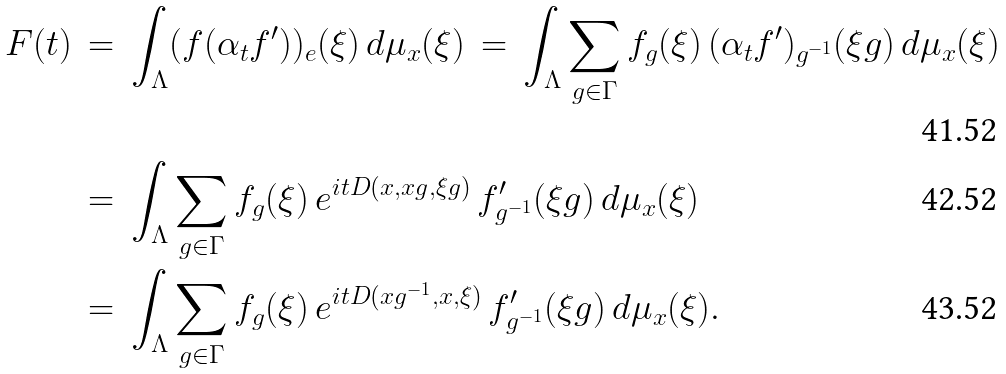Convert formula to latex. <formula><loc_0><loc_0><loc_500><loc_500>F ( t ) \, & = \, \int _ { \Lambda } ( f ( \alpha _ { t } f ^ { \prime } ) ) _ { e } ( \xi ) \, d \mu _ { x } ( \xi ) \, = \, \int _ { \Lambda } \sum _ { g \in \Gamma } f _ { g } ( \xi ) \, ( \alpha _ { t } f ^ { \prime } ) _ { g ^ { - 1 } } ( \xi g ) \, d \mu _ { x } ( \xi ) \\ & = \, \int _ { \Lambda } \sum _ { g \in \Gamma } f _ { g } ( \xi ) \, e ^ { i t D ( x , x g , \xi g ) } \, f ^ { \prime } _ { g ^ { - 1 } } ( \xi g ) \, d \mu _ { x } ( \xi ) \\ & = \, \int _ { \Lambda } \sum _ { g \in \Gamma } f _ { g } ( \xi ) \, e ^ { i t D ( x g ^ { - 1 } , x , \xi ) } \, f ^ { \prime } _ { g ^ { - 1 } } ( \xi g ) \, d \mu _ { x } ( \xi ) .</formula> 